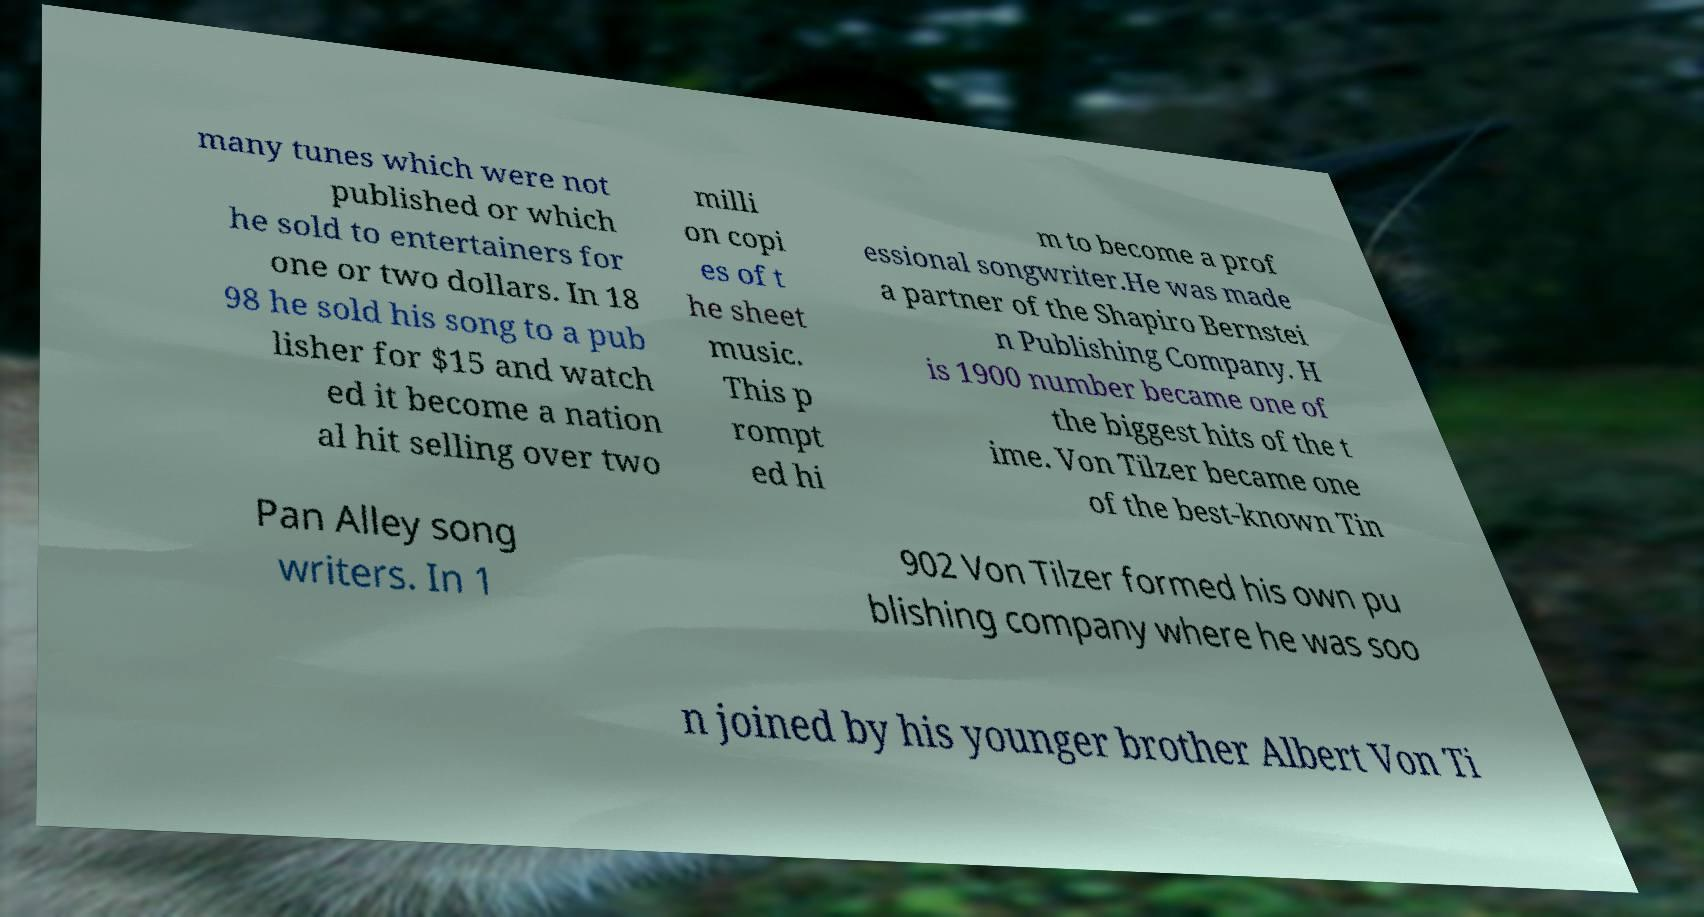Could you extract and type out the text from this image? many tunes which were not published or which he sold to entertainers for one or two dollars. In 18 98 he sold his song to a pub lisher for $15 and watch ed it become a nation al hit selling over two milli on copi es of t he sheet music. This p rompt ed hi m to become a prof essional songwriter.He was made a partner of the Shapiro Bernstei n Publishing Company. H is 1900 number became one of the biggest hits of the t ime. Von Tilzer became one of the best-known Tin Pan Alley song writers. In 1 902 Von Tilzer formed his own pu blishing company where he was soo n joined by his younger brother Albert Von Ti 